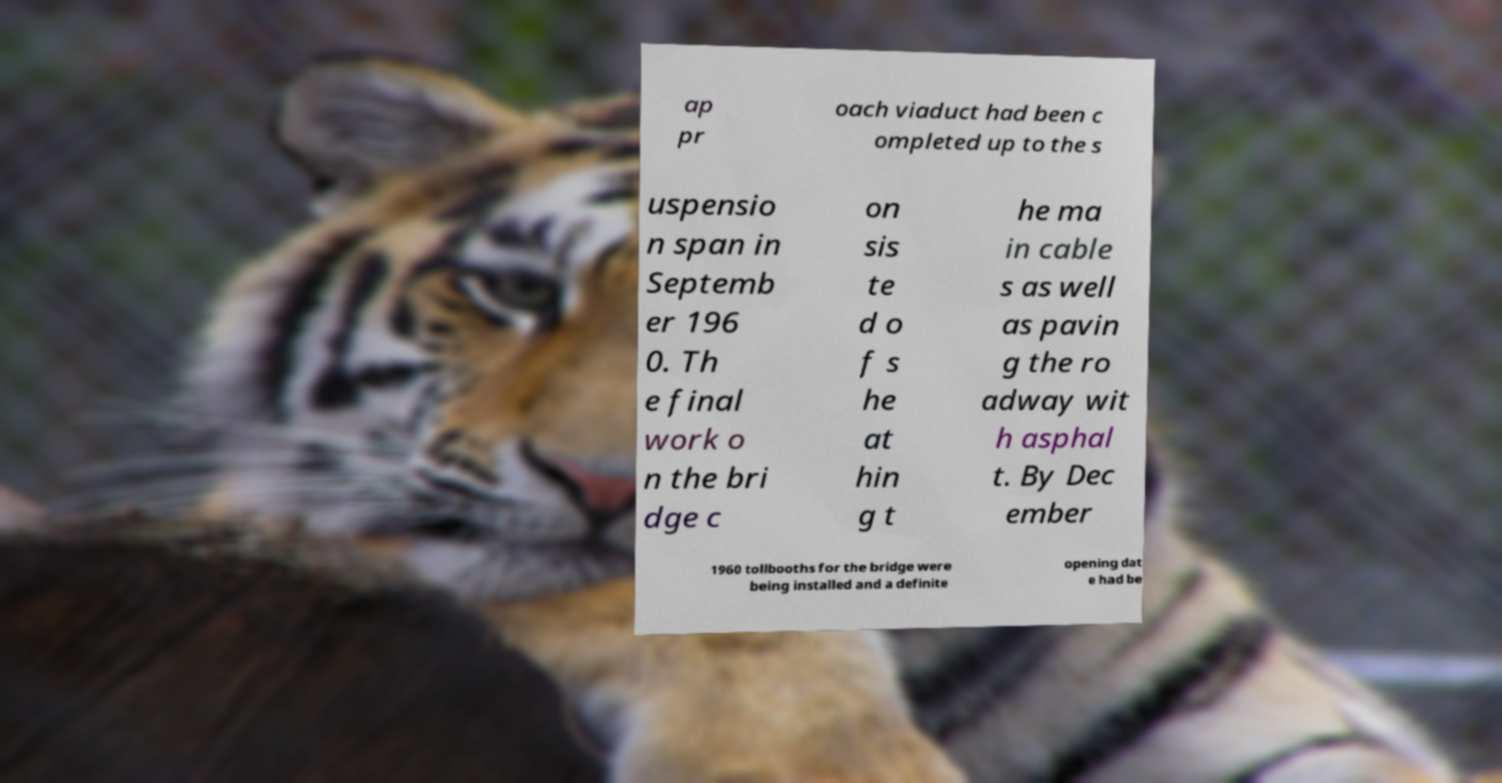I need the written content from this picture converted into text. Can you do that? ap pr oach viaduct had been c ompleted up to the s uspensio n span in Septemb er 196 0. Th e final work o n the bri dge c on sis te d o f s he at hin g t he ma in cable s as well as pavin g the ro adway wit h asphal t. By Dec ember 1960 tollbooths for the bridge were being installed and a definite opening dat e had be 